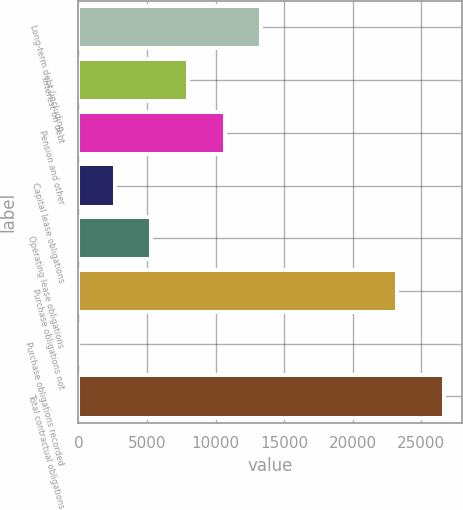Convert chart to OTSL. <chart><loc_0><loc_0><loc_500><loc_500><bar_chart><fcel>Long-term debt (including<fcel>Interest on debt<fcel>Pension and other<fcel>Capital lease obligations<fcel>Operating lease obligations<fcel>Purchase obligations not<fcel>Purchase obligations recorded<fcel>Total contractual obligations<nl><fcel>13319.5<fcel>7992.5<fcel>10656<fcel>2665.5<fcel>5329<fcel>23223<fcel>2<fcel>26637<nl></chart> 